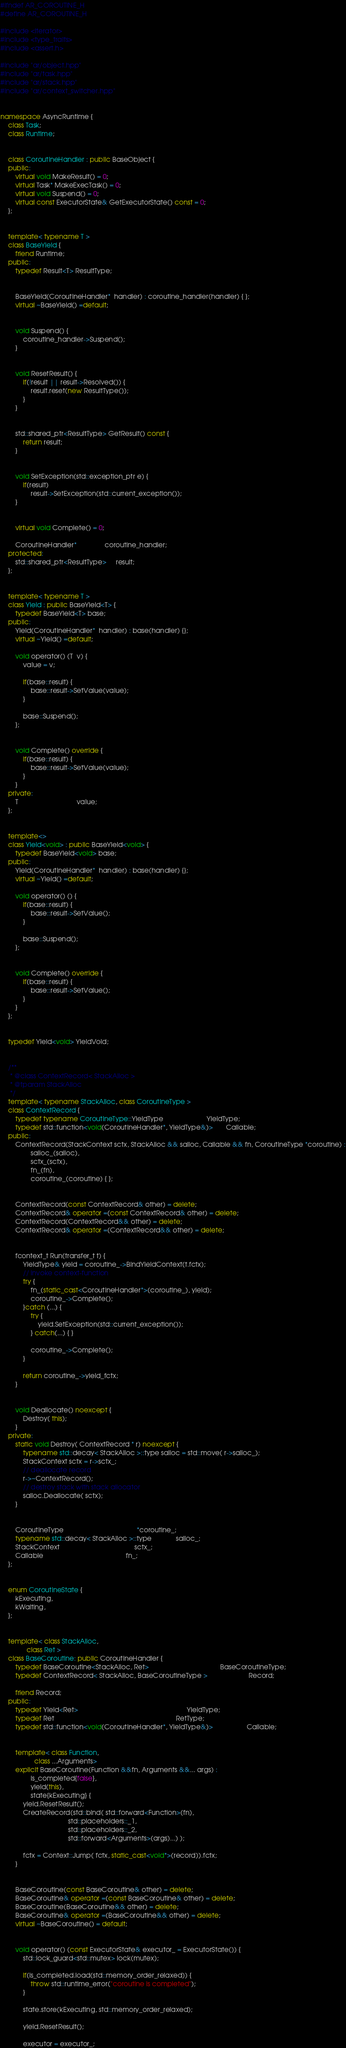Convert code to text. <code><loc_0><loc_0><loc_500><loc_500><_C++_>#ifndef AR_COROUTINE_H
#define AR_COROUTINE_H

#include <iterator>
#include <type_traits>
#include <assert.h>

#include "ar/object.hpp"
#include "ar/task.hpp"
#include "ar/stack.hpp"
#include "ar/context_switcher.hpp"


namespace AsyncRuntime {
    class Task;
    class Runtime;


    class CoroutineHandler : public BaseObject {
    public:
        virtual void MakeResult() = 0;
        virtual Task* MakeExecTask() = 0;
        virtual void Suspend() = 0;
        virtual const ExecutorState& GetExecutorState() const = 0;
    };


    template< typename T >
    class BaseYield {
        friend Runtime;
    public:
        typedef Result<T> ResultType;


        BaseYield(CoroutineHandler*  handler) : coroutine_handler(handler) { };
        virtual ~BaseYield() =default;


        void Suspend() {
            coroutine_handler->Suspend();
        }


        void ResetResult() {
            if(!result || result->Resolved()) {
                result.reset(new ResultType());
            }
        }


        std::shared_ptr<ResultType> GetResult() const {
            return result;
        }


        void SetException(std::exception_ptr e) {
            if(result)
                result->SetException(std::current_exception());
        }


        virtual void Complete() = 0;

        CoroutineHandler*               coroutine_handler;
    protected:
        std::shared_ptr<ResultType>     result;
    };


    template< typename T >
    class Yield : public BaseYield<T> {
        typedef BaseYield<T> base;
    public:
        Yield(CoroutineHandler*  handler) : base(handler) {};
        virtual ~Yield() =default;

        void operator() (T  v) {
            value = v;

            if(base::result) {
                base::result->SetValue(value);
            }

            base::Suspend();
        };


        void Complete() override {
            if(base::result) {
                base::result->SetValue(value);
            }
        }
    private:
        T                               value;
    };


    template<>
    class Yield<void> : public BaseYield<void> {
        typedef BaseYield<void> base;
    public:
        Yield(CoroutineHandler*  handler) : base(handler) {};
        virtual ~Yield() =default;

        void operator() () {
            if(base::result) {
                base::result->SetValue();
            }

            base::Suspend();
        };


        void Complete() override {
            if(base::result) {
                base::result->SetValue();
            }
        }
    };


    typedef Yield<void> YieldVoid;


    /**
     * @class ContextRecord< StackAlloc >
     * @tparam StackAlloc
     */
    template< typename StackAlloc, class CoroutineType >
    class ContextRecord {
        typedef typename CoroutineType::YieldType                       YieldType;
        typedef std::function<void(CoroutineHandler*, YieldType&)>       Callable;
    public:
        ContextRecord(StackContext sctx, StackAlloc && salloc, Callable && fn, CoroutineType *coroutine) :
                salloc_(salloc),
                sctx_(sctx),
                fn_(fn),
                coroutine_(coroutine) { };


        ContextRecord(const ContextRecord& other) = delete;
        ContextRecord& operator =(const ContextRecord& other) = delete;
        ContextRecord(ContextRecord&& other) = delete;
        ContextRecord& operator =(ContextRecord&& other) = delete;


        fcontext_t Run(transfer_t t) {
            YieldType& yield = coroutine_->BindYieldContext(t.fctx);
            // invoke context-function
            try {
                fn_(static_cast<CoroutineHandler*>(coroutine_), yield);
                coroutine_->Complete();
            }catch (...) {
                try {
                    yield.SetException(std::current_exception());
                } catch(...) { }

                coroutine_->Complete();
            }

            return coroutine_->yield_fctx;
        }


        void Deallocate() noexcept {
            Destroy( this);
        }
    private:
        static void Destroy( ContextRecord * r) noexcept {
            typename std::decay< StackAlloc >::type salloc = std::move( r->salloc_);
            StackContext sctx = r->sctx_;
            // deallocate record
            r->~ContextRecord();
            // destroy stack with stack allocator
            salloc.Deallocate( sctx);
        }


        CoroutineType                                       *coroutine_;
        typename std::decay< StackAlloc >::type             salloc_;
        StackContext                                        sctx_;
        Callable                                            fn_;
    };


    enum CoroutineState {
        kExecuting,
        kWaiting,
    };


    template< class StackAlloc,
              class Ret >
    class BaseCoroutine: public CoroutineHandler {
        typedef BaseCoroutine<StackAlloc, Ret>                                      BaseCoroutineType;
        typedef ContextRecord< StackAlloc, BaseCoroutineType >                      Record;

        friend Record;
    public:
        typedef Yield<Ret>                                                          YieldType;
        typedef Ret                                                                 RetType;
        typedef std::function<void(CoroutineHandler*, YieldType&)>                  Callable;


        template< class Function,
                  class ...Arguments>
        explicit BaseCoroutine(Function &&fn, Arguments &&... args) :
                is_completed{false},
                yield(this),
                state{kExecuting} {
            yield.ResetResult();
            CreateRecord(std::bind( std::forward<Function>(fn),
                                    std::placeholders::_1,
                                    std::placeholders::_2,
                                    std::forward<Arguments>(args)...) );

            fctx = Context::Jump( fctx, static_cast<void*>(record)).fctx;
        }


        BaseCoroutine(const BaseCoroutine& other) = delete;
        BaseCoroutine& operator =(const BaseCoroutine& other) = delete;
        BaseCoroutine(BaseCoroutine&& other) = delete;
        BaseCoroutine& operator =(BaseCoroutine&& other) = delete;
        virtual ~BaseCoroutine() = default;


        void operator() (const ExecutorState& executor_ = ExecutorState()) {
            std::lock_guard<std::mutex> lock(mutex);

            if(is_completed.load(std::memory_order_relaxed)) {
                throw std::runtime_error("coroutine is completed");
            }

            state.store(kExecuting, std::memory_order_relaxed);

            yield.ResetResult();

            executor = executor_;</code> 